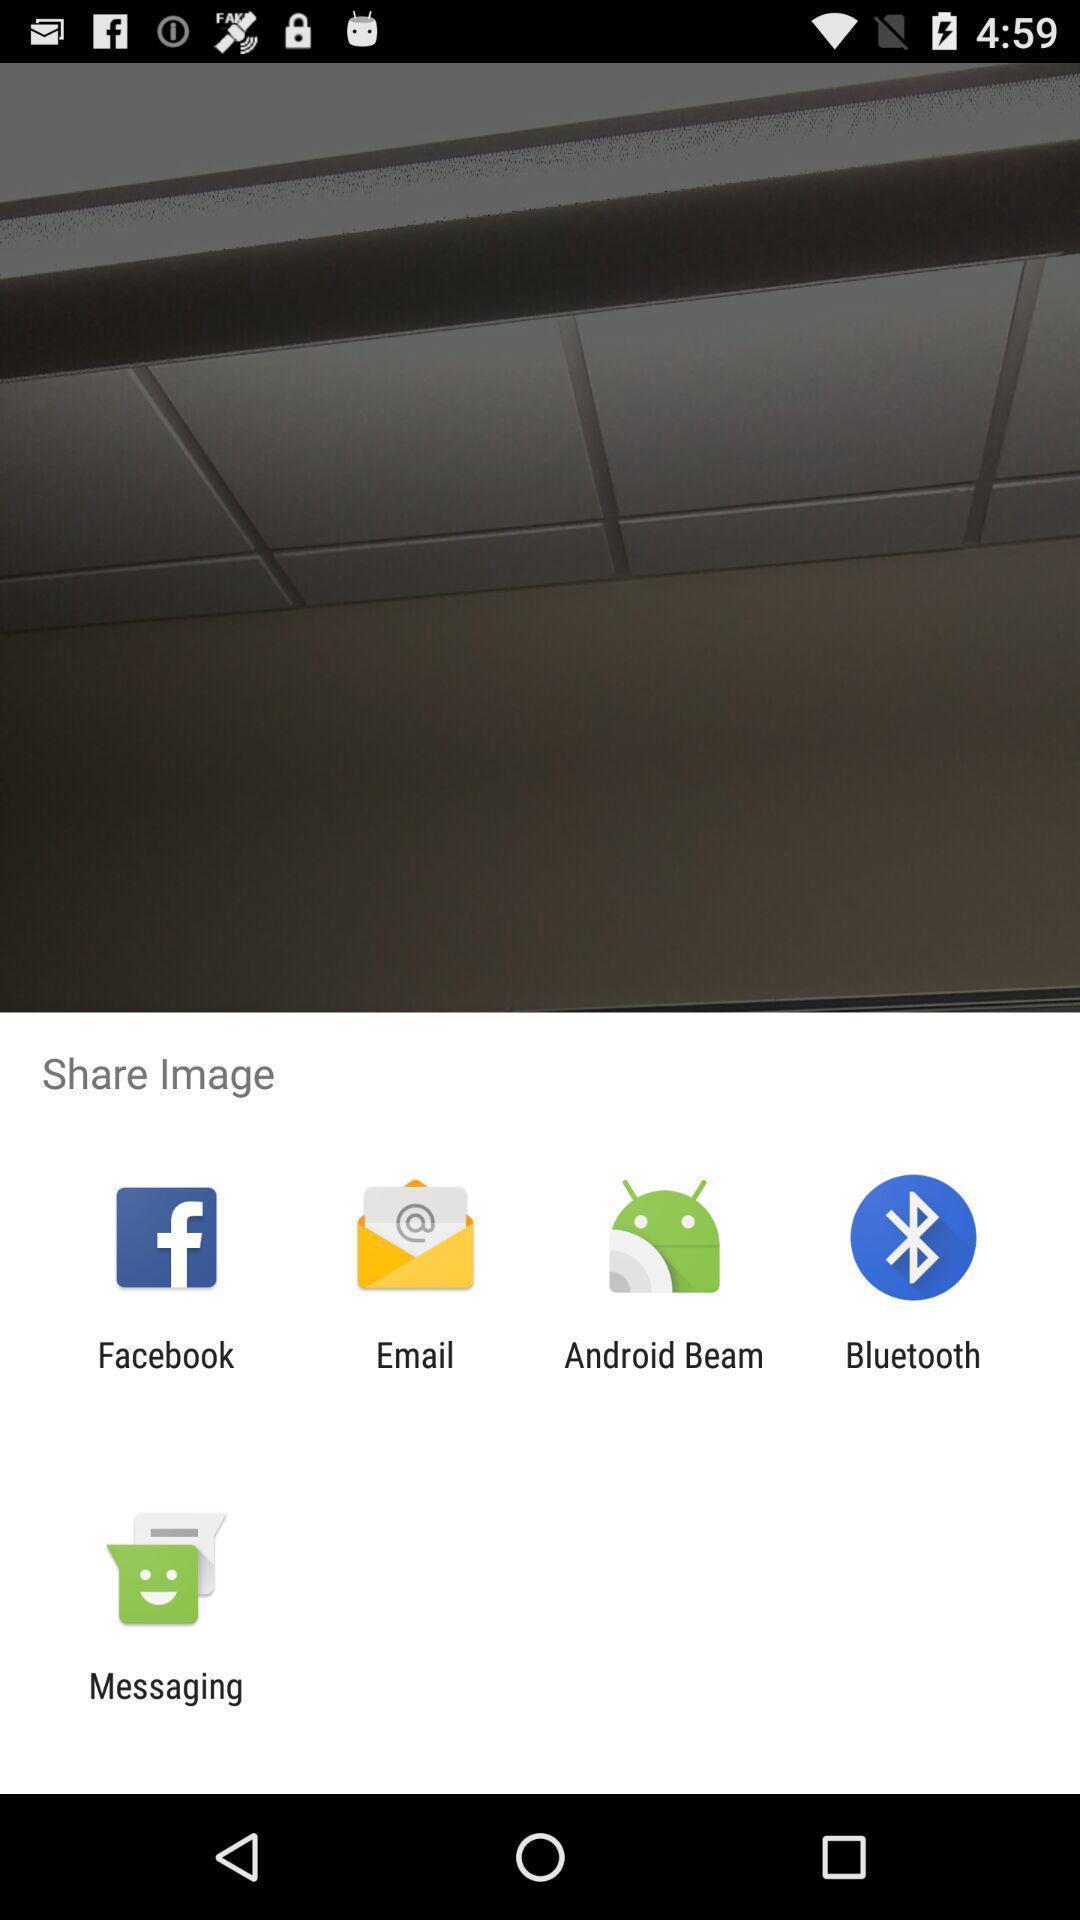Explain the elements present in this screenshot. Pop up to share the image with other apps. 